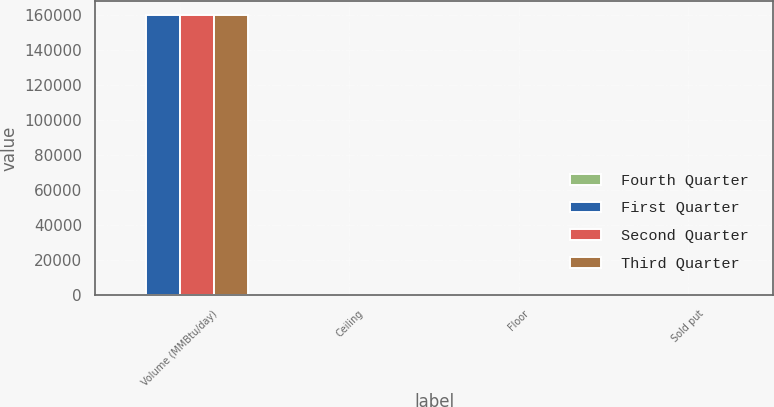<chart> <loc_0><loc_0><loc_500><loc_500><stacked_bar_chart><ecel><fcel>Volume (MMBtu/day)<fcel>Ceiling<fcel>Floor<fcel>Sold put<nl><fcel>Fourth Quarter<fcel>3.08<fcel>3.79<fcel>3.08<fcel>2.55<nl><fcel>First Quarter<fcel>160000<fcel>3.61<fcel>3<fcel>2.5<nl><fcel>Second Quarter<fcel>160000<fcel>3.61<fcel>3<fcel>2.5<nl><fcel>Third Quarter<fcel>160000<fcel>3.61<fcel>3<fcel>2.5<nl></chart> 